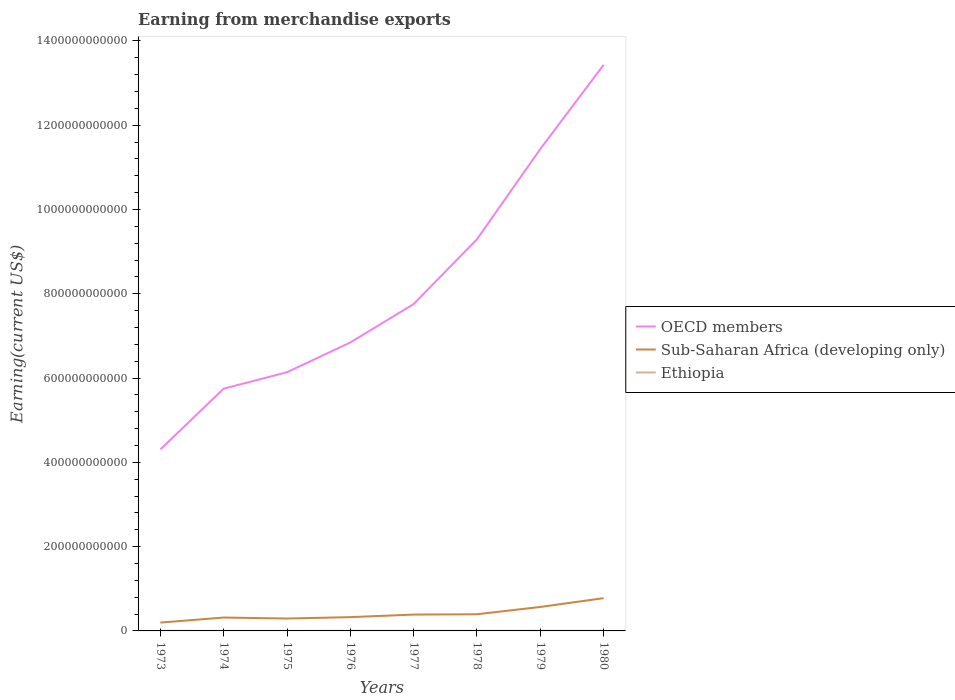Does the line corresponding to Sub-Saharan Africa (developing only) intersect with the line corresponding to OECD members?
Your answer should be compact. No. Across all years, what is the maximum amount earned from merchandise exports in Ethiopia?
Offer a terse response. 2.39e+08. In which year was the amount earned from merchandise exports in Sub-Saharan Africa (developing only) maximum?
Your response must be concise. 1973. What is the total amount earned from merchandise exports in Sub-Saharan Africa (developing only) in the graph?
Ensure brevity in your answer.  -1.98e+1. What is the difference between the highest and the second highest amount earned from merchandise exports in Sub-Saharan Africa (developing only)?
Ensure brevity in your answer.  5.80e+1. What is the difference between the highest and the lowest amount earned from merchandise exports in Sub-Saharan Africa (developing only)?
Give a very brief answer. 2. How many years are there in the graph?
Make the answer very short. 8. What is the difference between two consecutive major ticks on the Y-axis?
Offer a very short reply. 2.00e+11. Are the values on the major ticks of Y-axis written in scientific E-notation?
Offer a very short reply. No. Does the graph contain any zero values?
Offer a very short reply. No. What is the title of the graph?
Provide a succinct answer. Earning from merchandise exports. What is the label or title of the X-axis?
Your answer should be very brief. Years. What is the label or title of the Y-axis?
Provide a succinct answer. Earning(current US$). What is the Earning(current US$) in OECD members in 1973?
Make the answer very short. 4.31e+11. What is the Earning(current US$) of Sub-Saharan Africa (developing only) in 1973?
Offer a terse response. 1.98e+1. What is the Earning(current US$) of Ethiopia in 1973?
Offer a terse response. 2.39e+08. What is the Earning(current US$) of OECD members in 1974?
Provide a succinct answer. 5.75e+11. What is the Earning(current US$) in Sub-Saharan Africa (developing only) in 1974?
Give a very brief answer. 3.18e+1. What is the Earning(current US$) of Ethiopia in 1974?
Provide a succinct answer. 2.69e+08. What is the Earning(current US$) of OECD members in 1975?
Ensure brevity in your answer.  6.14e+11. What is the Earning(current US$) of Sub-Saharan Africa (developing only) in 1975?
Your response must be concise. 2.94e+1. What is the Earning(current US$) of Ethiopia in 1975?
Make the answer very short. 2.40e+08. What is the Earning(current US$) of OECD members in 1976?
Give a very brief answer. 6.85e+11. What is the Earning(current US$) of Sub-Saharan Africa (developing only) in 1976?
Give a very brief answer. 3.27e+1. What is the Earning(current US$) in Ethiopia in 1976?
Your response must be concise. 2.80e+08. What is the Earning(current US$) in OECD members in 1977?
Give a very brief answer. 7.76e+11. What is the Earning(current US$) in Sub-Saharan Africa (developing only) in 1977?
Provide a succinct answer. 3.88e+1. What is the Earning(current US$) in Ethiopia in 1977?
Provide a short and direct response. 3.33e+08. What is the Earning(current US$) of OECD members in 1978?
Ensure brevity in your answer.  9.29e+11. What is the Earning(current US$) of Sub-Saharan Africa (developing only) in 1978?
Provide a succinct answer. 3.95e+1. What is the Earning(current US$) of Ethiopia in 1978?
Provide a short and direct response. 3.06e+08. What is the Earning(current US$) in OECD members in 1979?
Keep it short and to the point. 1.14e+12. What is the Earning(current US$) in Sub-Saharan Africa (developing only) in 1979?
Your answer should be very brief. 5.69e+1. What is the Earning(current US$) of Ethiopia in 1979?
Give a very brief answer. 4.18e+08. What is the Earning(current US$) of OECD members in 1980?
Make the answer very short. 1.34e+12. What is the Earning(current US$) in Sub-Saharan Africa (developing only) in 1980?
Provide a short and direct response. 7.78e+1. What is the Earning(current US$) in Ethiopia in 1980?
Provide a succinct answer. 4.25e+08. Across all years, what is the maximum Earning(current US$) in OECD members?
Provide a short and direct response. 1.34e+12. Across all years, what is the maximum Earning(current US$) in Sub-Saharan Africa (developing only)?
Ensure brevity in your answer.  7.78e+1. Across all years, what is the maximum Earning(current US$) in Ethiopia?
Offer a very short reply. 4.25e+08. Across all years, what is the minimum Earning(current US$) in OECD members?
Your response must be concise. 4.31e+11. Across all years, what is the minimum Earning(current US$) of Sub-Saharan Africa (developing only)?
Offer a terse response. 1.98e+1. Across all years, what is the minimum Earning(current US$) of Ethiopia?
Keep it short and to the point. 2.39e+08. What is the total Earning(current US$) of OECD members in the graph?
Ensure brevity in your answer.  6.50e+12. What is the total Earning(current US$) in Sub-Saharan Africa (developing only) in the graph?
Provide a succinct answer. 3.27e+11. What is the total Earning(current US$) in Ethiopia in the graph?
Your answer should be very brief. 2.51e+09. What is the difference between the Earning(current US$) in OECD members in 1973 and that in 1974?
Your response must be concise. -1.44e+11. What is the difference between the Earning(current US$) in Sub-Saharan Africa (developing only) in 1973 and that in 1974?
Ensure brevity in your answer.  -1.20e+1. What is the difference between the Earning(current US$) in Ethiopia in 1973 and that in 1974?
Provide a succinct answer. -2.98e+07. What is the difference between the Earning(current US$) of OECD members in 1973 and that in 1975?
Give a very brief answer. -1.83e+11. What is the difference between the Earning(current US$) in Sub-Saharan Africa (developing only) in 1973 and that in 1975?
Offer a very short reply. -9.64e+09. What is the difference between the Earning(current US$) of Ethiopia in 1973 and that in 1975?
Your answer should be very brief. -1.62e+06. What is the difference between the Earning(current US$) of OECD members in 1973 and that in 1976?
Keep it short and to the point. -2.54e+11. What is the difference between the Earning(current US$) in Sub-Saharan Africa (developing only) in 1973 and that in 1976?
Offer a terse response. -1.29e+1. What is the difference between the Earning(current US$) of Ethiopia in 1973 and that in 1976?
Provide a short and direct response. -4.16e+07. What is the difference between the Earning(current US$) of OECD members in 1973 and that in 1977?
Provide a short and direct response. -3.45e+11. What is the difference between the Earning(current US$) in Sub-Saharan Africa (developing only) in 1973 and that in 1977?
Provide a short and direct response. -1.90e+1. What is the difference between the Earning(current US$) in Ethiopia in 1973 and that in 1977?
Give a very brief answer. -9.40e+07. What is the difference between the Earning(current US$) of OECD members in 1973 and that in 1978?
Give a very brief answer. -4.99e+11. What is the difference between the Earning(current US$) in Sub-Saharan Africa (developing only) in 1973 and that in 1978?
Give a very brief answer. -1.98e+1. What is the difference between the Earning(current US$) in Ethiopia in 1973 and that in 1978?
Provide a succinct answer. -6.72e+07. What is the difference between the Earning(current US$) in OECD members in 1973 and that in 1979?
Ensure brevity in your answer.  -7.13e+11. What is the difference between the Earning(current US$) in Sub-Saharan Africa (developing only) in 1973 and that in 1979?
Provide a succinct answer. -3.71e+1. What is the difference between the Earning(current US$) of Ethiopia in 1973 and that in 1979?
Provide a succinct answer. -1.79e+08. What is the difference between the Earning(current US$) in OECD members in 1973 and that in 1980?
Offer a very short reply. -9.13e+11. What is the difference between the Earning(current US$) of Sub-Saharan Africa (developing only) in 1973 and that in 1980?
Your answer should be very brief. -5.80e+1. What is the difference between the Earning(current US$) of Ethiopia in 1973 and that in 1980?
Offer a terse response. -1.86e+08. What is the difference between the Earning(current US$) in OECD members in 1974 and that in 1975?
Keep it short and to the point. -3.90e+1. What is the difference between the Earning(current US$) of Sub-Saharan Africa (developing only) in 1974 and that in 1975?
Your response must be concise. 2.37e+09. What is the difference between the Earning(current US$) in Ethiopia in 1974 and that in 1975?
Provide a succinct answer. 2.82e+07. What is the difference between the Earning(current US$) in OECD members in 1974 and that in 1976?
Offer a terse response. -1.10e+11. What is the difference between the Earning(current US$) of Sub-Saharan Africa (developing only) in 1974 and that in 1976?
Your answer should be compact. -8.99e+08. What is the difference between the Earning(current US$) in Ethiopia in 1974 and that in 1976?
Your answer should be very brief. -1.18e+07. What is the difference between the Earning(current US$) in OECD members in 1974 and that in 1977?
Your response must be concise. -2.01e+11. What is the difference between the Earning(current US$) of Sub-Saharan Africa (developing only) in 1974 and that in 1977?
Your answer should be compact. -6.98e+09. What is the difference between the Earning(current US$) of Ethiopia in 1974 and that in 1977?
Offer a very short reply. -6.41e+07. What is the difference between the Earning(current US$) of OECD members in 1974 and that in 1978?
Your response must be concise. -3.55e+11. What is the difference between the Earning(current US$) of Sub-Saharan Africa (developing only) in 1974 and that in 1978?
Offer a very short reply. -7.74e+09. What is the difference between the Earning(current US$) of Ethiopia in 1974 and that in 1978?
Keep it short and to the point. -3.74e+07. What is the difference between the Earning(current US$) of OECD members in 1974 and that in 1979?
Your answer should be very brief. -5.69e+11. What is the difference between the Earning(current US$) of Sub-Saharan Africa (developing only) in 1974 and that in 1979?
Make the answer very short. -2.51e+1. What is the difference between the Earning(current US$) in Ethiopia in 1974 and that in 1979?
Offer a very short reply. -1.49e+08. What is the difference between the Earning(current US$) in OECD members in 1974 and that in 1980?
Ensure brevity in your answer.  -7.68e+11. What is the difference between the Earning(current US$) in Sub-Saharan Africa (developing only) in 1974 and that in 1980?
Ensure brevity in your answer.  -4.60e+1. What is the difference between the Earning(current US$) in Ethiopia in 1974 and that in 1980?
Provide a short and direct response. -1.56e+08. What is the difference between the Earning(current US$) in OECD members in 1975 and that in 1976?
Ensure brevity in your answer.  -7.06e+1. What is the difference between the Earning(current US$) of Sub-Saharan Africa (developing only) in 1975 and that in 1976?
Give a very brief answer. -3.27e+09. What is the difference between the Earning(current US$) of Ethiopia in 1975 and that in 1976?
Your answer should be compact. -4.00e+07. What is the difference between the Earning(current US$) in OECD members in 1975 and that in 1977?
Offer a terse response. -1.62e+11. What is the difference between the Earning(current US$) in Sub-Saharan Africa (developing only) in 1975 and that in 1977?
Offer a very short reply. -9.35e+09. What is the difference between the Earning(current US$) in Ethiopia in 1975 and that in 1977?
Provide a succinct answer. -9.23e+07. What is the difference between the Earning(current US$) of OECD members in 1975 and that in 1978?
Your answer should be compact. -3.16e+11. What is the difference between the Earning(current US$) of Sub-Saharan Africa (developing only) in 1975 and that in 1978?
Provide a succinct answer. -1.01e+1. What is the difference between the Earning(current US$) in Ethiopia in 1975 and that in 1978?
Your response must be concise. -6.56e+07. What is the difference between the Earning(current US$) of OECD members in 1975 and that in 1979?
Keep it short and to the point. -5.30e+11. What is the difference between the Earning(current US$) of Sub-Saharan Africa (developing only) in 1975 and that in 1979?
Your answer should be very brief. -2.75e+1. What is the difference between the Earning(current US$) of Ethiopia in 1975 and that in 1979?
Provide a short and direct response. -1.77e+08. What is the difference between the Earning(current US$) in OECD members in 1975 and that in 1980?
Provide a succinct answer. -7.29e+11. What is the difference between the Earning(current US$) in Sub-Saharan Africa (developing only) in 1975 and that in 1980?
Make the answer very short. -4.83e+1. What is the difference between the Earning(current US$) of Ethiopia in 1975 and that in 1980?
Ensure brevity in your answer.  -1.85e+08. What is the difference between the Earning(current US$) in OECD members in 1976 and that in 1977?
Offer a terse response. -9.12e+1. What is the difference between the Earning(current US$) of Sub-Saharan Africa (developing only) in 1976 and that in 1977?
Provide a succinct answer. -6.08e+09. What is the difference between the Earning(current US$) in Ethiopia in 1976 and that in 1977?
Give a very brief answer. -5.24e+07. What is the difference between the Earning(current US$) in OECD members in 1976 and that in 1978?
Give a very brief answer. -2.45e+11. What is the difference between the Earning(current US$) of Sub-Saharan Africa (developing only) in 1976 and that in 1978?
Your response must be concise. -6.84e+09. What is the difference between the Earning(current US$) in Ethiopia in 1976 and that in 1978?
Your response must be concise. -2.56e+07. What is the difference between the Earning(current US$) in OECD members in 1976 and that in 1979?
Give a very brief answer. -4.59e+11. What is the difference between the Earning(current US$) in Sub-Saharan Africa (developing only) in 1976 and that in 1979?
Make the answer very short. -2.42e+1. What is the difference between the Earning(current US$) in Ethiopia in 1976 and that in 1979?
Make the answer very short. -1.37e+08. What is the difference between the Earning(current US$) of OECD members in 1976 and that in 1980?
Keep it short and to the point. -6.59e+11. What is the difference between the Earning(current US$) of Sub-Saharan Africa (developing only) in 1976 and that in 1980?
Offer a very short reply. -4.51e+1. What is the difference between the Earning(current US$) in Ethiopia in 1976 and that in 1980?
Ensure brevity in your answer.  -1.45e+08. What is the difference between the Earning(current US$) in OECD members in 1977 and that in 1978?
Keep it short and to the point. -1.54e+11. What is the difference between the Earning(current US$) in Sub-Saharan Africa (developing only) in 1977 and that in 1978?
Provide a short and direct response. -7.65e+08. What is the difference between the Earning(current US$) in Ethiopia in 1977 and that in 1978?
Provide a short and direct response. 2.67e+07. What is the difference between the Earning(current US$) of OECD members in 1977 and that in 1979?
Your answer should be compact. -3.68e+11. What is the difference between the Earning(current US$) of Sub-Saharan Africa (developing only) in 1977 and that in 1979?
Keep it short and to the point. -1.81e+1. What is the difference between the Earning(current US$) in Ethiopia in 1977 and that in 1979?
Your response must be concise. -8.47e+07. What is the difference between the Earning(current US$) in OECD members in 1977 and that in 1980?
Your response must be concise. -5.68e+11. What is the difference between the Earning(current US$) of Sub-Saharan Africa (developing only) in 1977 and that in 1980?
Your answer should be compact. -3.90e+1. What is the difference between the Earning(current US$) of Ethiopia in 1977 and that in 1980?
Keep it short and to the point. -9.22e+07. What is the difference between the Earning(current US$) in OECD members in 1978 and that in 1979?
Your answer should be compact. -2.14e+11. What is the difference between the Earning(current US$) of Sub-Saharan Africa (developing only) in 1978 and that in 1979?
Make the answer very short. -1.74e+1. What is the difference between the Earning(current US$) in Ethiopia in 1978 and that in 1979?
Ensure brevity in your answer.  -1.11e+08. What is the difference between the Earning(current US$) in OECD members in 1978 and that in 1980?
Ensure brevity in your answer.  -4.14e+11. What is the difference between the Earning(current US$) of Sub-Saharan Africa (developing only) in 1978 and that in 1980?
Your answer should be compact. -3.82e+1. What is the difference between the Earning(current US$) in Ethiopia in 1978 and that in 1980?
Ensure brevity in your answer.  -1.19e+08. What is the difference between the Earning(current US$) in OECD members in 1979 and that in 1980?
Offer a terse response. -2.00e+11. What is the difference between the Earning(current US$) of Sub-Saharan Africa (developing only) in 1979 and that in 1980?
Your response must be concise. -2.09e+1. What is the difference between the Earning(current US$) of Ethiopia in 1979 and that in 1980?
Provide a short and direct response. -7.45e+06. What is the difference between the Earning(current US$) of OECD members in 1973 and the Earning(current US$) of Sub-Saharan Africa (developing only) in 1974?
Keep it short and to the point. 3.99e+11. What is the difference between the Earning(current US$) of OECD members in 1973 and the Earning(current US$) of Ethiopia in 1974?
Your response must be concise. 4.30e+11. What is the difference between the Earning(current US$) of Sub-Saharan Africa (developing only) in 1973 and the Earning(current US$) of Ethiopia in 1974?
Offer a very short reply. 1.95e+1. What is the difference between the Earning(current US$) in OECD members in 1973 and the Earning(current US$) in Sub-Saharan Africa (developing only) in 1975?
Your answer should be compact. 4.01e+11. What is the difference between the Earning(current US$) of OECD members in 1973 and the Earning(current US$) of Ethiopia in 1975?
Offer a very short reply. 4.31e+11. What is the difference between the Earning(current US$) of Sub-Saharan Africa (developing only) in 1973 and the Earning(current US$) of Ethiopia in 1975?
Your response must be concise. 1.95e+1. What is the difference between the Earning(current US$) of OECD members in 1973 and the Earning(current US$) of Sub-Saharan Africa (developing only) in 1976?
Your answer should be very brief. 3.98e+11. What is the difference between the Earning(current US$) of OECD members in 1973 and the Earning(current US$) of Ethiopia in 1976?
Ensure brevity in your answer.  4.30e+11. What is the difference between the Earning(current US$) of Sub-Saharan Africa (developing only) in 1973 and the Earning(current US$) of Ethiopia in 1976?
Offer a terse response. 1.95e+1. What is the difference between the Earning(current US$) in OECD members in 1973 and the Earning(current US$) in Sub-Saharan Africa (developing only) in 1977?
Make the answer very short. 3.92e+11. What is the difference between the Earning(current US$) in OECD members in 1973 and the Earning(current US$) in Ethiopia in 1977?
Make the answer very short. 4.30e+11. What is the difference between the Earning(current US$) of Sub-Saharan Africa (developing only) in 1973 and the Earning(current US$) of Ethiopia in 1977?
Provide a succinct answer. 1.94e+1. What is the difference between the Earning(current US$) of OECD members in 1973 and the Earning(current US$) of Sub-Saharan Africa (developing only) in 1978?
Ensure brevity in your answer.  3.91e+11. What is the difference between the Earning(current US$) in OECD members in 1973 and the Earning(current US$) in Ethiopia in 1978?
Ensure brevity in your answer.  4.30e+11. What is the difference between the Earning(current US$) in Sub-Saharan Africa (developing only) in 1973 and the Earning(current US$) in Ethiopia in 1978?
Give a very brief answer. 1.95e+1. What is the difference between the Earning(current US$) of OECD members in 1973 and the Earning(current US$) of Sub-Saharan Africa (developing only) in 1979?
Offer a terse response. 3.74e+11. What is the difference between the Earning(current US$) of OECD members in 1973 and the Earning(current US$) of Ethiopia in 1979?
Your response must be concise. 4.30e+11. What is the difference between the Earning(current US$) in Sub-Saharan Africa (developing only) in 1973 and the Earning(current US$) in Ethiopia in 1979?
Offer a very short reply. 1.94e+1. What is the difference between the Earning(current US$) of OECD members in 1973 and the Earning(current US$) of Sub-Saharan Africa (developing only) in 1980?
Give a very brief answer. 3.53e+11. What is the difference between the Earning(current US$) in OECD members in 1973 and the Earning(current US$) in Ethiopia in 1980?
Offer a very short reply. 4.30e+11. What is the difference between the Earning(current US$) in Sub-Saharan Africa (developing only) in 1973 and the Earning(current US$) in Ethiopia in 1980?
Keep it short and to the point. 1.94e+1. What is the difference between the Earning(current US$) of OECD members in 1974 and the Earning(current US$) of Sub-Saharan Africa (developing only) in 1975?
Provide a succinct answer. 5.45e+11. What is the difference between the Earning(current US$) of OECD members in 1974 and the Earning(current US$) of Ethiopia in 1975?
Make the answer very short. 5.75e+11. What is the difference between the Earning(current US$) in Sub-Saharan Africa (developing only) in 1974 and the Earning(current US$) in Ethiopia in 1975?
Offer a very short reply. 3.16e+1. What is the difference between the Earning(current US$) of OECD members in 1974 and the Earning(current US$) of Sub-Saharan Africa (developing only) in 1976?
Offer a very short reply. 5.42e+11. What is the difference between the Earning(current US$) of OECD members in 1974 and the Earning(current US$) of Ethiopia in 1976?
Provide a succinct answer. 5.75e+11. What is the difference between the Earning(current US$) in Sub-Saharan Africa (developing only) in 1974 and the Earning(current US$) in Ethiopia in 1976?
Your answer should be compact. 3.15e+1. What is the difference between the Earning(current US$) of OECD members in 1974 and the Earning(current US$) of Sub-Saharan Africa (developing only) in 1977?
Your answer should be very brief. 5.36e+11. What is the difference between the Earning(current US$) of OECD members in 1974 and the Earning(current US$) of Ethiopia in 1977?
Ensure brevity in your answer.  5.75e+11. What is the difference between the Earning(current US$) of Sub-Saharan Africa (developing only) in 1974 and the Earning(current US$) of Ethiopia in 1977?
Ensure brevity in your answer.  3.15e+1. What is the difference between the Earning(current US$) in OECD members in 1974 and the Earning(current US$) in Sub-Saharan Africa (developing only) in 1978?
Offer a very short reply. 5.35e+11. What is the difference between the Earning(current US$) in OECD members in 1974 and the Earning(current US$) in Ethiopia in 1978?
Offer a very short reply. 5.75e+11. What is the difference between the Earning(current US$) of Sub-Saharan Africa (developing only) in 1974 and the Earning(current US$) of Ethiopia in 1978?
Offer a terse response. 3.15e+1. What is the difference between the Earning(current US$) in OECD members in 1974 and the Earning(current US$) in Sub-Saharan Africa (developing only) in 1979?
Provide a succinct answer. 5.18e+11. What is the difference between the Earning(current US$) of OECD members in 1974 and the Earning(current US$) of Ethiopia in 1979?
Offer a terse response. 5.74e+11. What is the difference between the Earning(current US$) in Sub-Saharan Africa (developing only) in 1974 and the Earning(current US$) in Ethiopia in 1979?
Your answer should be compact. 3.14e+1. What is the difference between the Earning(current US$) in OECD members in 1974 and the Earning(current US$) in Sub-Saharan Africa (developing only) in 1980?
Provide a short and direct response. 4.97e+11. What is the difference between the Earning(current US$) in OECD members in 1974 and the Earning(current US$) in Ethiopia in 1980?
Give a very brief answer. 5.74e+11. What is the difference between the Earning(current US$) of Sub-Saharan Africa (developing only) in 1974 and the Earning(current US$) of Ethiopia in 1980?
Ensure brevity in your answer.  3.14e+1. What is the difference between the Earning(current US$) in OECD members in 1975 and the Earning(current US$) in Sub-Saharan Africa (developing only) in 1976?
Keep it short and to the point. 5.81e+11. What is the difference between the Earning(current US$) in OECD members in 1975 and the Earning(current US$) in Ethiopia in 1976?
Give a very brief answer. 6.14e+11. What is the difference between the Earning(current US$) in Sub-Saharan Africa (developing only) in 1975 and the Earning(current US$) in Ethiopia in 1976?
Provide a succinct answer. 2.91e+1. What is the difference between the Earning(current US$) in OECD members in 1975 and the Earning(current US$) in Sub-Saharan Africa (developing only) in 1977?
Provide a short and direct response. 5.75e+11. What is the difference between the Earning(current US$) in OECD members in 1975 and the Earning(current US$) in Ethiopia in 1977?
Your answer should be very brief. 6.14e+11. What is the difference between the Earning(current US$) of Sub-Saharan Africa (developing only) in 1975 and the Earning(current US$) of Ethiopia in 1977?
Your answer should be very brief. 2.91e+1. What is the difference between the Earning(current US$) of OECD members in 1975 and the Earning(current US$) of Sub-Saharan Africa (developing only) in 1978?
Ensure brevity in your answer.  5.74e+11. What is the difference between the Earning(current US$) of OECD members in 1975 and the Earning(current US$) of Ethiopia in 1978?
Your answer should be very brief. 6.14e+11. What is the difference between the Earning(current US$) in Sub-Saharan Africa (developing only) in 1975 and the Earning(current US$) in Ethiopia in 1978?
Your response must be concise. 2.91e+1. What is the difference between the Earning(current US$) of OECD members in 1975 and the Earning(current US$) of Sub-Saharan Africa (developing only) in 1979?
Ensure brevity in your answer.  5.57e+11. What is the difference between the Earning(current US$) in OECD members in 1975 and the Earning(current US$) in Ethiopia in 1979?
Offer a very short reply. 6.13e+11. What is the difference between the Earning(current US$) of Sub-Saharan Africa (developing only) in 1975 and the Earning(current US$) of Ethiopia in 1979?
Give a very brief answer. 2.90e+1. What is the difference between the Earning(current US$) in OECD members in 1975 and the Earning(current US$) in Sub-Saharan Africa (developing only) in 1980?
Give a very brief answer. 5.36e+11. What is the difference between the Earning(current US$) of OECD members in 1975 and the Earning(current US$) of Ethiopia in 1980?
Give a very brief answer. 6.13e+11. What is the difference between the Earning(current US$) in Sub-Saharan Africa (developing only) in 1975 and the Earning(current US$) in Ethiopia in 1980?
Your answer should be compact. 2.90e+1. What is the difference between the Earning(current US$) in OECD members in 1976 and the Earning(current US$) in Sub-Saharan Africa (developing only) in 1977?
Offer a terse response. 6.46e+11. What is the difference between the Earning(current US$) of OECD members in 1976 and the Earning(current US$) of Ethiopia in 1977?
Your response must be concise. 6.84e+11. What is the difference between the Earning(current US$) in Sub-Saharan Africa (developing only) in 1976 and the Earning(current US$) in Ethiopia in 1977?
Ensure brevity in your answer.  3.24e+1. What is the difference between the Earning(current US$) in OECD members in 1976 and the Earning(current US$) in Sub-Saharan Africa (developing only) in 1978?
Keep it short and to the point. 6.45e+11. What is the difference between the Earning(current US$) of OECD members in 1976 and the Earning(current US$) of Ethiopia in 1978?
Your answer should be compact. 6.84e+11. What is the difference between the Earning(current US$) in Sub-Saharan Africa (developing only) in 1976 and the Earning(current US$) in Ethiopia in 1978?
Your response must be concise. 3.24e+1. What is the difference between the Earning(current US$) in OECD members in 1976 and the Earning(current US$) in Sub-Saharan Africa (developing only) in 1979?
Offer a terse response. 6.28e+11. What is the difference between the Earning(current US$) in OECD members in 1976 and the Earning(current US$) in Ethiopia in 1979?
Make the answer very short. 6.84e+11. What is the difference between the Earning(current US$) in Sub-Saharan Africa (developing only) in 1976 and the Earning(current US$) in Ethiopia in 1979?
Your response must be concise. 3.23e+1. What is the difference between the Earning(current US$) in OECD members in 1976 and the Earning(current US$) in Sub-Saharan Africa (developing only) in 1980?
Ensure brevity in your answer.  6.07e+11. What is the difference between the Earning(current US$) in OECD members in 1976 and the Earning(current US$) in Ethiopia in 1980?
Offer a very short reply. 6.84e+11. What is the difference between the Earning(current US$) in Sub-Saharan Africa (developing only) in 1976 and the Earning(current US$) in Ethiopia in 1980?
Your response must be concise. 3.23e+1. What is the difference between the Earning(current US$) of OECD members in 1977 and the Earning(current US$) of Sub-Saharan Africa (developing only) in 1978?
Offer a terse response. 7.36e+11. What is the difference between the Earning(current US$) in OECD members in 1977 and the Earning(current US$) in Ethiopia in 1978?
Your response must be concise. 7.75e+11. What is the difference between the Earning(current US$) in Sub-Saharan Africa (developing only) in 1977 and the Earning(current US$) in Ethiopia in 1978?
Give a very brief answer. 3.85e+1. What is the difference between the Earning(current US$) in OECD members in 1977 and the Earning(current US$) in Sub-Saharan Africa (developing only) in 1979?
Ensure brevity in your answer.  7.19e+11. What is the difference between the Earning(current US$) of OECD members in 1977 and the Earning(current US$) of Ethiopia in 1979?
Provide a short and direct response. 7.75e+11. What is the difference between the Earning(current US$) of Sub-Saharan Africa (developing only) in 1977 and the Earning(current US$) of Ethiopia in 1979?
Offer a terse response. 3.84e+1. What is the difference between the Earning(current US$) of OECD members in 1977 and the Earning(current US$) of Sub-Saharan Africa (developing only) in 1980?
Offer a terse response. 6.98e+11. What is the difference between the Earning(current US$) of OECD members in 1977 and the Earning(current US$) of Ethiopia in 1980?
Keep it short and to the point. 7.75e+11. What is the difference between the Earning(current US$) in Sub-Saharan Africa (developing only) in 1977 and the Earning(current US$) in Ethiopia in 1980?
Offer a very short reply. 3.83e+1. What is the difference between the Earning(current US$) in OECD members in 1978 and the Earning(current US$) in Sub-Saharan Africa (developing only) in 1979?
Give a very brief answer. 8.73e+11. What is the difference between the Earning(current US$) in OECD members in 1978 and the Earning(current US$) in Ethiopia in 1979?
Your answer should be compact. 9.29e+11. What is the difference between the Earning(current US$) of Sub-Saharan Africa (developing only) in 1978 and the Earning(current US$) of Ethiopia in 1979?
Keep it short and to the point. 3.91e+1. What is the difference between the Earning(current US$) in OECD members in 1978 and the Earning(current US$) in Sub-Saharan Africa (developing only) in 1980?
Offer a very short reply. 8.52e+11. What is the difference between the Earning(current US$) in OECD members in 1978 and the Earning(current US$) in Ethiopia in 1980?
Provide a short and direct response. 9.29e+11. What is the difference between the Earning(current US$) in Sub-Saharan Africa (developing only) in 1978 and the Earning(current US$) in Ethiopia in 1980?
Keep it short and to the point. 3.91e+1. What is the difference between the Earning(current US$) of OECD members in 1979 and the Earning(current US$) of Sub-Saharan Africa (developing only) in 1980?
Your answer should be compact. 1.07e+12. What is the difference between the Earning(current US$) of OECD members in 1979 and the Earning(current US$) of Ethiopia in 1980?
Ensure brevity in your answer.  1.14e+12. What is the difference between the Earning(current US$) in Sub-Saharan Africa (developing only) in 1979 and the Earning(current US$) in Ethiopia in 1980?
Give a very brief answer. 5.65e+1. What is the average Earning(current US$) of OECD members per year?
Make the answer very short. 8.12e+11. What is the average Earning(current US$) in Sub-Saharan Africa (developing only) per year?
Ensure brevity in your answer.  4.08e+1. What is the average Earning(current US$) in Ethiopia per year?
Keep it short and to the point. 3.14e+08. In the year 1973, what is the difference between the Earning(current US$) of OECD members and Earning(current US$) of Sub-Saharan Africa (developing only)?
Your answer should be compact. 4.11e+11. In the year 1973, what is the difference between the Earning(current US$) in OECD members and Earning(current US$) in Ethiopia?
Ensure brevity in your answer.  4.31e+11. In the year 1973, what is the difference between the Earning(current US$) in Sub-Saharan Africa (developing only) and Earning(current US$) in Ethiopia?
Your answer should be compact. 1.95e+1. In the year 1974, what is the difference between the Earning(current US$) in OECD members and Earning(current US$) in Sub-Saharan Africa (developing only)?
Provide a succinct answer. 5.43e+11. In the year 1974, what is the difference between the Earning(current US$) in OECD members and Earning(current US$) in Ethiopia?
Provide a short and direct response. 5.75e+11. In the year 1974, what is the difference between the Earning(current US$) of Sub-Saharan Africa (developing only) and Earning(current US$) of Ethiopia?
Ensure brevity in your answer.  3.15e+1. In the year 1975, what is the difference between the Earning(current US$) of OECD members and Earning(current US$) of Sub-Saharan Africa (developing only)?
Offer a very short reply. 5.84e+11. In the year 1975, what is the difference between the Earning(current US$) of OECD members and Earning(current US$) of Ethiopia?
Your response must be concise. 6.14e+11. In the year 1975, what is the difference between the Earning(current US$) in Sub-Saharan Africa (developing only) and Earning(current US$) in Ethiopia?
Keep it short and to the point. 2.92e+1. In the year 1976, what is the difference between the Earning(current US$) in OECD members and Earning(current US$) in Sub-Saharan Africa (developing only)?
Keep it short and to the point. 6.52e+11. In the year 1976, what is the difference between the Earning(current US$) of OECD members and Earning(current US$) of Ethiopia?
Give a very brief answer. 6.84e+11. In the year 1976, what is the difference between the Earning(current US$) in Sub-Saharan Africa (developing only) and Earning(current US$) in Ethiopia?
Your answer should be very brief. 3.24e+1. In the year 1977, what is the difference between the Earning(current US$) of OECD members and Earning(current US$) of Sub-Saharan Africa (developing only)?
Your answer should be compact. 7.37e+11. In the year 1977, what is the difference between the Earning(current US$) in OECD members and Earning(current US$) in Ethiopia?
Offer a very short reply. 7.75e+11. In the year 1977, what is the difference between the Earning(current US$) in Sub-Saharan Africa (developing only) and Earning(current US$) in Ethiopia?
Make the answer very short. 3.84e+1. In the year 1978, what is the difference between the Earning(current US$) in OECD members and Earning(current US$) in Sub-Saharan Africa (developing only)?
Make the answer very short. 8.90e+11. In the year 1978, what is the difference between the Earning(current US$) of OECD members and Earning(current US$) of Ethiopia?
Offer a very short reply. 9.29e+11. In the year 1978, what is the difference between the Earning(current US$) of Sub-Saharan Africa (developing only) and Earning(current US$) of Ethiopia?
Your response must be concise. 3.92e+1. In the year 1979, what is the difference between the Earning(current US$) of OECD members and Earning(current US$) of Sub-Saharan Africa (developing only)?
Keep it short and to the point. 1.09e+12. In the year 1979, what is the difference between the Earning(current US$) of OECD members and Earning(current US$) of Ethiopia?
Your answer should be compact. 1.14e+12. In the year 1979, what is the difference between the Earning(current US$) of Sub-Saharan Africa (developing only) and Earning(current US$) of Ethiopia?
Make the answer very short. 5.65e+1. In the year 1980, what is the difference between the Earning(current US$) of OECD members and Earning(current US$) of Sub-Saharan Africa (developing only)?
Offer a terse response. 1.27e+12. In the year 1980, what is the difference between the Earning(current US$) in OECD members and Earning(current US$) in Ethiopia?
Ensure brevity in your answer.  1.34e+12. In the year 1980, what is the difference between the Earning(current US$) in Sub-Saharan Africa (developing only) and Earning(current US$) in Ethiopia?
Give a very brief answer. 7.73e+1. What is the ratio of the Earning(current US$) in OECD members in 1973 to that in 1974?
Offer a very short reply. 0.75. What is the ratio of the Earning(current US$) in Sub-Saharan Africa (developing only) in 1973 to that in 1974?
Offer a very short reply. 0.62. What is the ratio of the Earning(current US$) in Ethiopia in 1973 to that in 1974?
Your answer should be compact. 0.89. What is the ratio of the Earning(current US$) of OECD members in 1973 to that in 1975?
Keep it short and to the point. 0.7. What is the ratio of the Earning(current US$) in Sub-Saharan Africa (developing only) in 1973 to that in 1975?
Make the answer very short. 0.67. What is the ratio of the Earning(current US$) in Ethiopia in 1973 to that in 1975?
Keep it short and to the point. 0.99. What is the ratio of the Earning(current US$) of OECD members in 1973 to that in 1976?
Offer a very short reply. 0.63. What is the ratio of the Earning(current US$) in Sub-Saharan Africa (developing only) in 1973 to that in 1976?
Provide a short and direct response. 0.6. What is the ratio of the Earning(current US$) in Ethiopia in 1973 to that in 1976?
Make the answer very short. 0.85. What is the ratio of the Earning(current US$) of OECD members in 1973 to that in 1977?
Provide a succinct answer. 0.56. What is the ratio of the Earning(current US$) of Sub-Saharan Africa (developing only) in 1973 to that in 1977?
Provide a short and direct response. 0.51. What is the ratio of the Earning(current US$) in Ethiopia in 1973 to that in 1977?
Keep it short and to the point. 0.72. What is the ratio of the Earning(current US$) in OECD members in 1973 to that in 1978?
Offer a terse response. 0.46. What is the ratio of the Earning(current US$) in Sub-Saharan Africa (developing only) in 1973 to that in 1978?
Your answer should be very brief. 0.5. What is the ratio of the Earning(current US$) of Ethiopia in 1973 to that in 1978?
Offer a very short reply. 0.78. What is the ratio of the Earning(current US$) of OECD members in 1973 to that in 1979?
Offer a terse response. 0.38. What is the ratio of the Earning(current US$) in Sub-Saharan Africa (developing only) in 1973 to that in 1979?
Give a very brief answer. 0.35. What is the ratio of the Earning(current US$) of Ethiopia in 1973 to that in 1979?
Provide a short and direct response. 0.57. What is the ratio of the Earning(current US$) in OECD members in 1973 to that in 1980?
Provide a succinct answer. 0.32. What is the ratio of the Earning(current US$) of Sub-Saharan Africa (developing only) in 1973 to that in 1980?
Offer a very short reply. 0.25. What is the ratio of the Earning(current US$) in Ethiopia in 1973 to that in 1980?
Your response must be concise. 0.56. What is the ratio of the Earning(current US$) of OECD members in 1974 to that in 1975?
Provide a short and direct response. 0.94. What is the ratio of the Earning(current US$) of Sub-Saharan Africa (developing only) in 1974 to that in 1975?
Make the answer very short. 1.08. What is the ratio of the Earning(current US$) of Ethiopia in 1974 to that in 1975?
Make the answer very short. 1.12. What is the ratio of the Earning(current US$) in OECD members in 1974 to that in 1976?
Make the answer very short. 0.84. What is the ratio of the Earning(current US$) of Sub-Saharan Africa (developing only) in 1974 to that in 1976?
Provide a short and direct response. 0.97. What is the ratio of the Earning(current US$) of Ethiopia in 1974 to that in 1976?
Provide a short and direct response. 0.96. What is the ratio of the Earning(current US$) of OECD members in 1974 to that in 1977?
Ensure brevity in your answer.  0.74. What is the ratio of the Earning(current US$) in Sub-Saharan Africa (developing only) in 1974 to that in 1977?
Offer a very short reply. 0.82. What is the ratio of the Earning(current US$) in Ethiopia in 1974 to that in 1977?
Give a very brief answer. 0.81. What is the ratio of the Earning(current US$) of OECD members in 1974 to that in 1978?
Make the answer very short. 0.62. What is the ratio of the Earning(current US$) in Sub-Saharan Africa (developing only) in 1974 to that in 1978?
Offer a very short reply. 0.8. What is the ratio of the Earning(current US$) in Ethiopia in 1974 to that in 1978?
Keep it short and to the point. 0.88. What is the ratio of the Earning(current US$) of OECD members in 1974 to that in 1979?
Your answer should be compact. 0.5. What is the ratio of the Earning(current US$) in Sub-Saharan Africa (developing only) in 1974 to that in 1979?
Your response must be concise. 0.56. What is the ratio of the Earning(current US$) of Ethiopia in 1974 to that in 1979?
Give a very brief answer. 0.64. What is the ratio of the Earning(current US$) in OECD members in 1974 to that in 1980?
Offer a very short reply. 0.43. What is the ratio of the Earning(current US$) of Sub-Saharan Africa (developing only) in 1974 to that in 1980?
Your response must be concise. 0.41. What is the ratio of the Earning(current US$) of Ethiopia in 1974 to that in 1980?
Provide a succinct answer. 0.63. What is the ratio of the Earning(current US$) of OECD members in 1975 to that in 1976?
Your answer should be compact. 0.9. What is the ratio of the Earning(current US$) in Ethiopia in 1975 to that in 1976?
Your answer should be very brief. 0.86. What is the ratio of the Earning(current US$) of OECD members in 1975 to that in 1977?
Your answer should be very brief. 0.79. What is the ratio of the Earning(current US$) in Sub-Saharan Africa (developing only) in 1975 to that in 1977?
Offer a terse response. 0.76. What is the ratio of the Earning(current US$) in Ethiopia in 1975 to that in 1977?
Your answer should be very brief. 0.72. What is the ratio of the Earning(current US$) of OECD members in 1975 to that in 1978?
Your answer should be very brief. 0.66. What is the ratio of the Earning(current US$) of Sub-Saharan Africa (developing only) in 1975 to that in 1978?
Your answer should be very brief. 0.74. What is the ratio of the Earning(current US$) of Ethiopia in 1975 to that in 1978?
Your answer should be compact. 0.79. What is the ratio of the Earning(current US$) in OECD members in 1975 to that in 1979?
Provide a succinct answer. 0.54. What is the ratio of the Earning(current US$) of Sub-Saharan Africa (developing only) in 1975 to that in 1979?
Ensure brevity in your answer.  0.52. What is the ratio of the Earning(current US$) of Ethiopia in 1975 to that in 1979?
Offer a terse response. 0.58. What is the ratio of the Earning(current US$) in OECD members in 1975 to that in 1980?
Offer a very short reply. 0.46. What is the ratio of the Earning(current US$) of Sub-Saharan Africa (developing only) in 1975 to that in 1980?
Offer a terse response. 0.38. What is the ratio of the Earning(current US$) of Ethiopia in 1975 to that in 1980?
Your answer should be compact. 0.57. What is the ratio of the Earning(current US$) of OECD members in 1976 to that in 1977?
Your answer should be very brief. 0.88. What is the ratio of the Earning(current US$) of Sub-Saharan Africa (developing only) in 1976 to that in 1977?
Offer a very short reply. 0.84. What is the ratio of the Earning(current US$) of Ethiopia in 1976 to that in 1977?
Make the answer very short. 0.84. What is the ratio of the Earning(current US$) in OECD members in 1976 to that in 1978?
Provide a short and direct response. 0.74. What is the ratio of the Earning(current US$) of Sub-Saharan Africa (developing only) in 1976 to that in 1978?
Ensure brevity in your answer.  0.83. What is the ratio of the Earning(current US$) in Ethiopia in 1976 to that in 1978?
Your answer should be compact. 0.92. What is the ratio of the Earning(current US$) of OECD members in 1976 to that in 1979?
Offer a terse response. 0.6. What is the ratio of the Earning(current US$) of Sub-Saharan Africa (developing only) in 1976 to that in 1979?
Ensure brevity in your answer.  0.57. What is the ratio of the Earning(current US$) of Ethiopia in 1976 to that in 1979?
Your response must be concise. 0.67. What is the ratio of the Earning(current US$) of OECD members in 1976 to that in 1980?
Ensure brevity in your answer.  0.51. What is the ratio of the Earning(current US$) of Sub-Saharan Africa (developing only) in 1976 to that in 1980?
Provide a succinct answer. 0.42. What is the ratio of the Earning(current US$) of Ethiopia in 1976 to that in 1980?
Provide a succinct answer. 0.66. What is the ratio of the Earning(current US$) in OECD members in 1977 to that in 1978?
Provide a succinct answer. 0.83. What is the ratio of the Earning(current US$) of Sub-Saharan Africa (developing only) in 1977 to that in 1978?
Provide a succinct answer. 0.98. What is the ratio of the Earning(current US$) in Ethiopia in 1977 to that in 1978?
Offer a very short reply. 1.09. What is the ratio of the Earning(current US$) in OECD members in 1977 to that in 1979?
Give a very brief answer. 0.68. What is the ratio of the Earning(current US$) of Sub-Saharan Africa (developing only) in 1977 to that in 1979?
Keep it short and to the point. 0.68. What is the ratio of the Earning(current US$) in Ethiopia in 1977 to that in 1979?
Provide a succinct answer. 0.8. What is the ratio of the Earning(current US$) in OECD members in 1977 to that in 1980?
Give a very brief answer. 0.58. What is the ratio of the Earning(current US$) in Sub-Saharan Africa (developing only) in 1977 to that in 1980?
Keep it short and to the point. 0.5. What is the ratio of the Earning(current US$) of Ethiopia in 1977 to that in 1980?
Your answer should be very brief. 0.78. What is the ratio of the Earning(current US$) of OECD members in 1978 to that in 1979?
Provide a short and direct response. 0.81. What is the ratio of the Earning(current US$) of Sub-Saharan Africa (developing only) in 1978 to that in 1979?
Provide a short and direct response. 0.69. What is the ratio of the Earning(current US$) of Ethiopia in 1978 to that in 1979?
Your answer should be very brief. 0.73. What is the ratio of the Earning(current US$) of OECD members in 1978 to that in 1980?
Provide a succinct answer. 0.69. What is the ratio of the Earning(current US$) in Sub-Saharan Africa (developing only) in 1978 to that in 1980?
Make the answer very short. 0.51. What is the ratio of the Earning(current US$) of Ethiopia in 1978 to that in 1980?
Your answer should be very brief. 0.72. What is the ratio of the Earning(current US$) of OECD members in 1979 to that in 1980?
Offer a terse response. 0.85. What is the ratio of the Earning(current US$) in Sub-Saharan Africa (developing only) in 1979 to that in 1980?
Your answer should be compact. 0.73. What is the ratio of the Earning(current US$) of Ethiopia in 1979 to that in 1980?
Ensure brevity in your answer.  0.98. What is the difference between the highest and the second highest Earning(current US$) of OECD members?
Your response must be concise. 2.00e+11. What is the difference between the highest and the second highest Earning(current US$) of Sub-Saharan Africa (developing only)?
Offer a very short reply. 2.09e+1. What is the difference between the highest and the second highest Earning(current US$) of Ethiopia?
Make the answer very short. 7.45e+06. What is the difference between the highest and the lowest Earning(current US$) of OECD members?
Your response must be concise. 9.13e+11. What is the difference between the highest and the lowest Earning(current US$) of Sub-Saharan Africa (developing only)?
Keep it short and to the point. 5.80e+1. What is the difference between the highest and the lowest Earning(current US$) of Ethiopia?
Your answer should be very brief. 1.86e+08. 